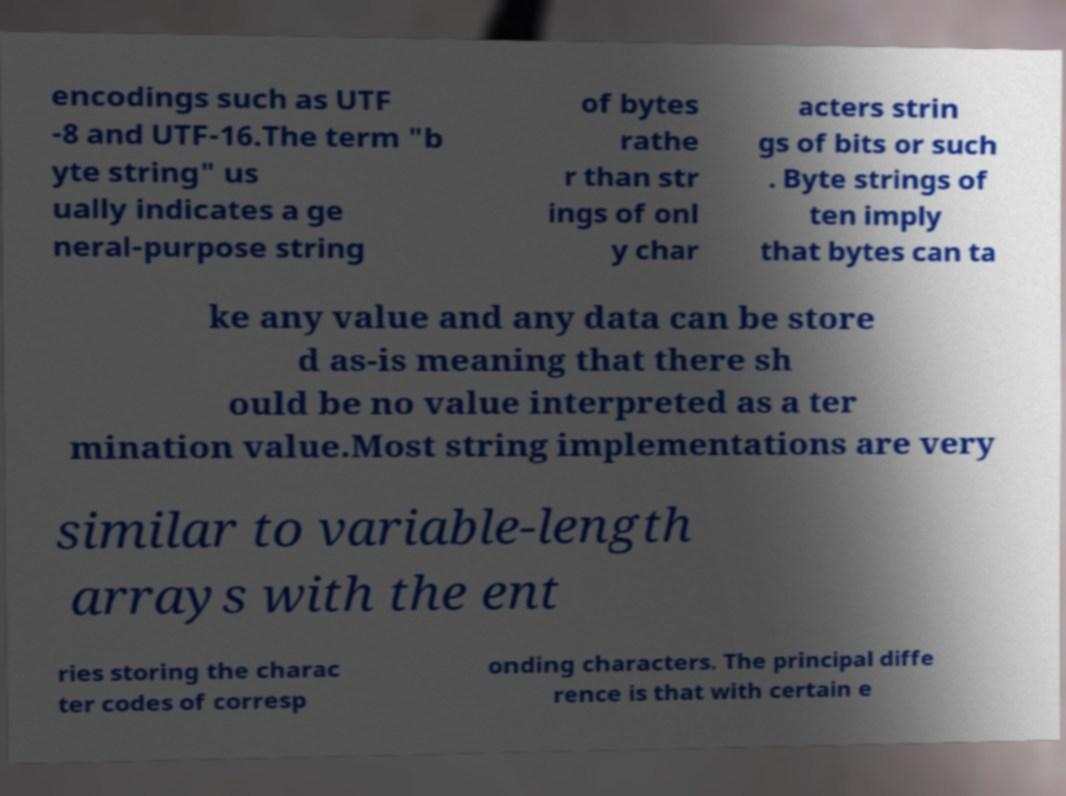Could you extract and type out the text from this image? encodings such as UTF -8 and UTF-16.The term "b yte string" us ually indicates a ge neral-purpose string of bytes rathe r than str ings of onl y char acters strin gs of bits or such . Byte strings of ten imply that bytes can ta ke any value and any data can be store d as-is meaning that there sh ould be no value interpreted as a ter mination value.Most string implementations are very similar to variable-length arrays with the ent ries storing the charac ter codes of corresp onding characters. The principal diffe rence is that with certain e 